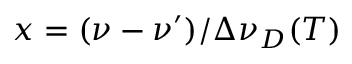Convert formula to latex. <formula><loc_0><loc_0><loc_500><loc_500>x = ( \nu - \nu ^ { \prime } ) / \Delta \nu _ { D } ( T )</formula> 